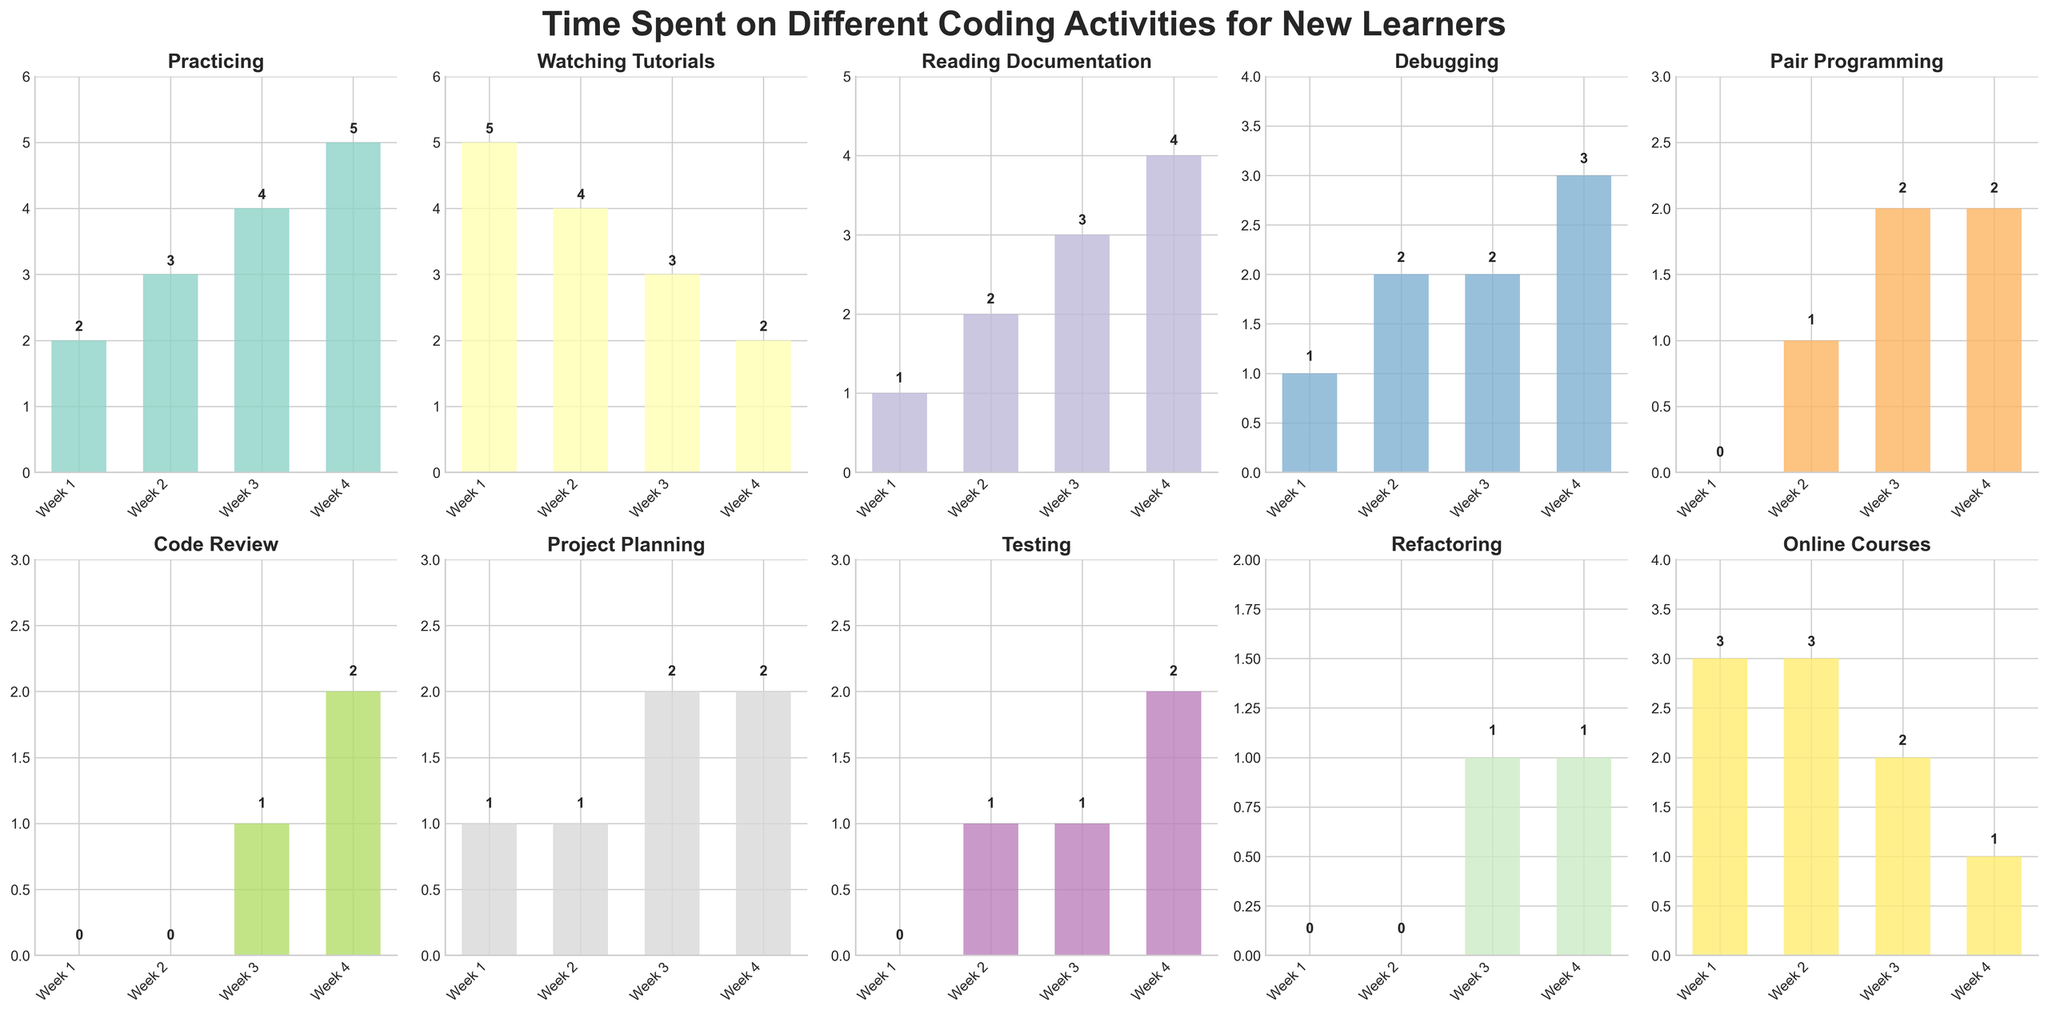How many total hours were spent on Debugging in Week 2 and Week 4 combined? First, find the hours for Debugging in Week 2 and Week 4. In Week 2, Debugging is 2 hours, and in Week 4, it is 3 hours. Add these two values together: 2 + 3 = 5 hours.
Answer: 5 Which activity had the highest increase in time spent from Week 1 to Week 4? To find this, we need to look at the change in hours for each activity from Week 1 to Week 4 and identify the largest increase. "Practicing" increased from 2 hours in Week 1 to 5 hours in Week 4, which is an increase of 3 hours. This is the highest increase.
Answer: Practicing Between Week 2 and Week 3, which activity experienced the biggest decrease in hours? We need to look at the difference in hours from Week 2 to Week 3 for all activities. "Watching Tutorials" decreased from 4 hours in Week 2 to 3 hours in Week 3, which is a decrease of 1 hour. Compare this to find that it's the biggest decrease among all activities.
Answer: Watching Tutorials Which two activities had the same total time spent over the 4 weeks? Add up the hours for each activity over all 4 weeks. "Pair Programming": 0 + 1 + 2 + 2 = 5 hours and "Debugging": 1 + 2 + 2 + 3 = 8 hours; "Code Review": 0 + 0 + 1 + 2 = 3 hours and "Refactoring": 0 + 0 + 1 + 1 = 2 hours. "Pair Programming" and "Reading Documentation": 1 + 2 + 3 + 4 = 10 hours; thus, no two activities have the same total.
Answer: None What is the average time spent on "Online Courses" per week? Add the weekly hours spent on "Online Courses" and divide by the number of weeks: (3 + 3 + 2 + 1) / 4 = 9 / 4 = 2.25 hours.
Answer: 2.25 Which week had the most total hours spent on all activities combined? Add the hours for each activity per week: 
Week 1: 2 + 5 + 1 + 1 + 0 + 0 + 1 + 0 + 0 + 3 = 13 hours, 
Week 2: 3 + 4 + 2 + 2 + 1 + 0 + 1 + 1 + 0 + 3 = 17 hours, 
Week 3: 4 + 3 + 3 + 2 + 2 + 1 + 2 + 1 + 1 + 2 = 21 hours, 
Week 4: 5 + 2 + 4 + 3 + 2 + 2 + 2 + 2 + 1 + 1 = 24 hours. 
Week 4 has the most total hours.
Answer: Week 4 Which activity showed no time spent during the first week? Look at the bars for Week 1. "Pair Programming", "Code Review", "Testing", and "Refactoring" each have 0 hours in Week 1.
Answer: Pair Programming, Code Review, Testing, Refactoring Which activity had a constantly increasing trend over the 4 weeks? Examine the trend for each activity from Week 1 to Week 4. Only "Practicing" and "Reading Documentation" continuously increased each week (2, 3, 4, 5) and (1, 2, 3, 4) respectively.
Answer: Practicing, Reading Documentation 